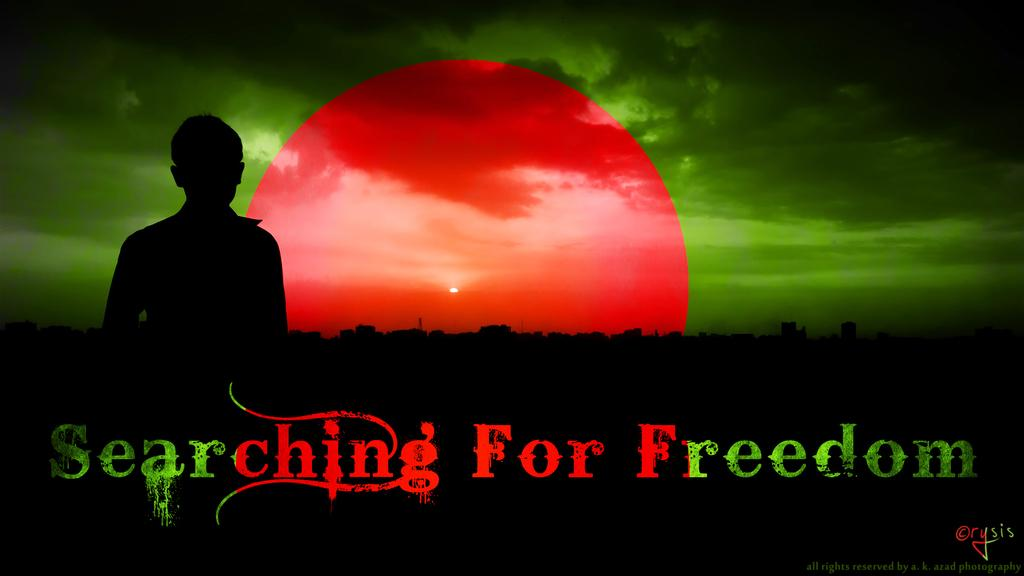<image>
Provide a brief description of the given image. Ad saying Searching for Freedom in red and green. 